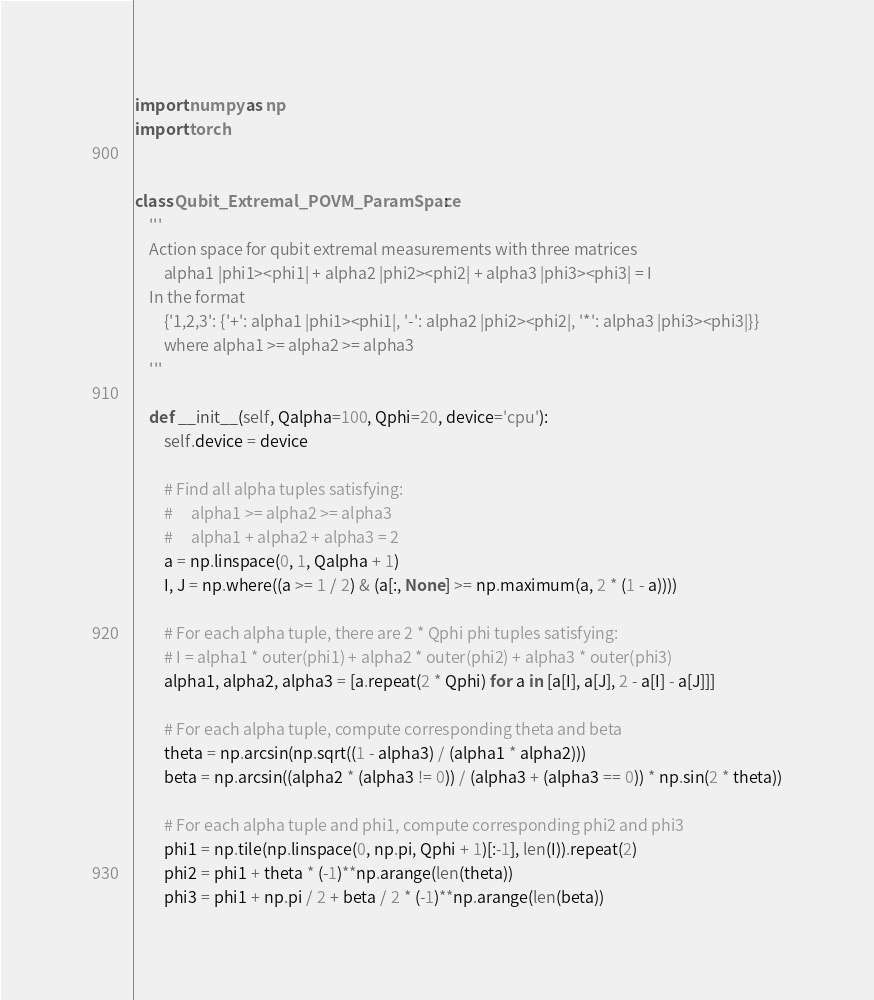Convert code to text. <code><loc_0><loc_0><loc_500><loc_500><_Python_>import numpy as np
import torch


class Qubit_Extremal_POVM_ParamSpace:
    '''
    Action space for qubit extremal measurements with three matrices
        alpha1 |phi1><phi1| + alpha2 |phi2><phi2| + alpha3 |phi3><phi3| = I
    In the format
        {'1,2,3': {'+': alpha1 |phi1><phi1|, '-': alpha2 |phi2><phi2|, '*': alpha3 |phi3><phi3|}}
        where alpha1 >= alpha2 >= alpha3
    '''

    def __init__(self, Qalpha=100, Qphi=20, device='cpu'):
        self.device = device

        # Find all alpha tuples satisfying:
        #     alpha1 >= alpha2 >= alpha3
        #     alpha1 + alpha2 + alpha3 = 2
        a = np.linspace(0, 1, Qalpha + 1)
        I, J = np.where((a >= 1 / 2) & (a[:, None] >= np.maximum(a, 2 * (1 - a))))

        # For each alpha tuple, there are 2 * Qphi phi tuples satisfying:
        # I = alpha1 * outer(phi1) + alpha2 * outer(phi2) + alpha3 * outer(phi3)
        alpha1, alpha2, alpha3 = [a.repeat(2 * Qphi) for a in [a[I], a[J], 2 - a[I] - a[J]]]

        # For each alpha tuple, compute corresponding theta and beta
        theta = np.arcsin(np.sqrt((1 - alpha3) / (alpha1 * alpha2)))
        beta = np.arcsin((alpha2 * (alpha3 != 0)) / (alpha3 + (alpha3 == 0)) * np.sin(2 * theta))

        # For each alpha tuple and phi1, compute corresponding phi2 and phi3
        phi1 = np.tile(np.linspace(0, np.pi, Qphi + 1)[:-1], len(I)).repeat(2)
        phi2 = phi1 + theta * (-1)**np.arange(len(theta))
        phi3 = phi1 + np.pi / 2 + beta / 2 * (-1)**np.arange(len(beta))
</code> 